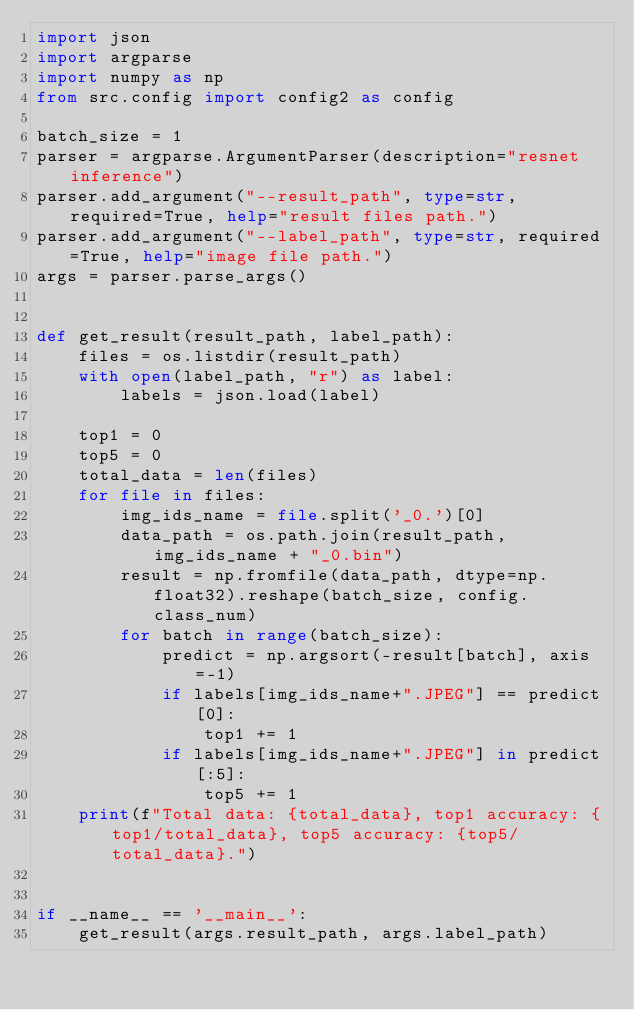Convert code to text. <code><loc_0><loc_0><loc_500><loc_500><_Python_>import json
import argparse
import numpy as np
from src.config import config2 as config

batch_size = 1
parser = argparse.ArgumentParser(description="resnet inference")
parser.add_argument("--result_path", type=str, required=True, help="result files path.")
parser.add_argument("--label_path", type=str, required=True, help="image file path.")
args = parser.parse_args()


def get_result(result_path, label_path):
    files = os.listdir(result_path)
    with open(label_path, "r") as label:
        labels = json.load(label)

    top1 = 0
    top5 = 0
    total_data = len(files)
    for file in files:
        img_ids_name = file.split('_0.')[0]
        data_path = os.path.join(result_path, img_ids_name + "_0.bin")
        result = np.fromfile(data_path, dtype=np.float32).reshape(batch_size, config.class_num)
        for batch in range(batch_size):
            predict = np.argsort(-result[batch], axis=-1)
            if labels[img_ids_name+".JPEG"] == predict[0]:
                top1 += 1
            if labels[img_ids_name+".JPEG"] in predict[:5]:
                top5 += 1
    print(f"Total data: {total_data}, top1 accuracy: {top1/total_data}, top5 accuracy: {top5/total_data}.")


if __name__ == '__main__':
    get_result(args.result_path, args.label_path)
</code> 